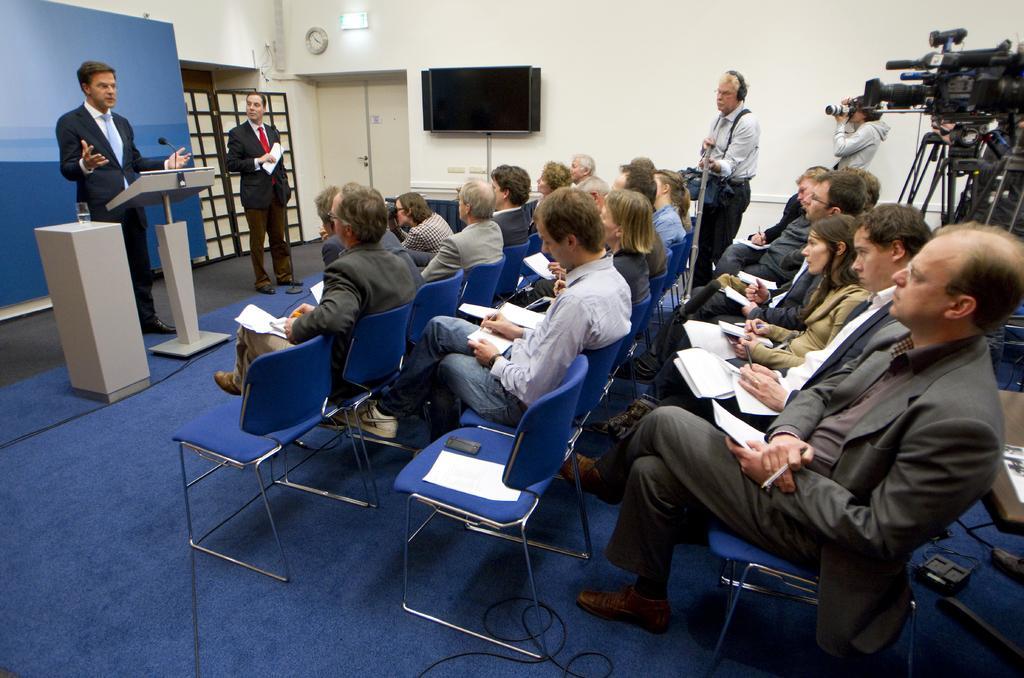Could you give a brief overview of what you see in this image? There are group of people sitting in chairs and holding some papers and there are two persons standing in front of them were one among them is speaking in front of mic and there are camera in front of them. 